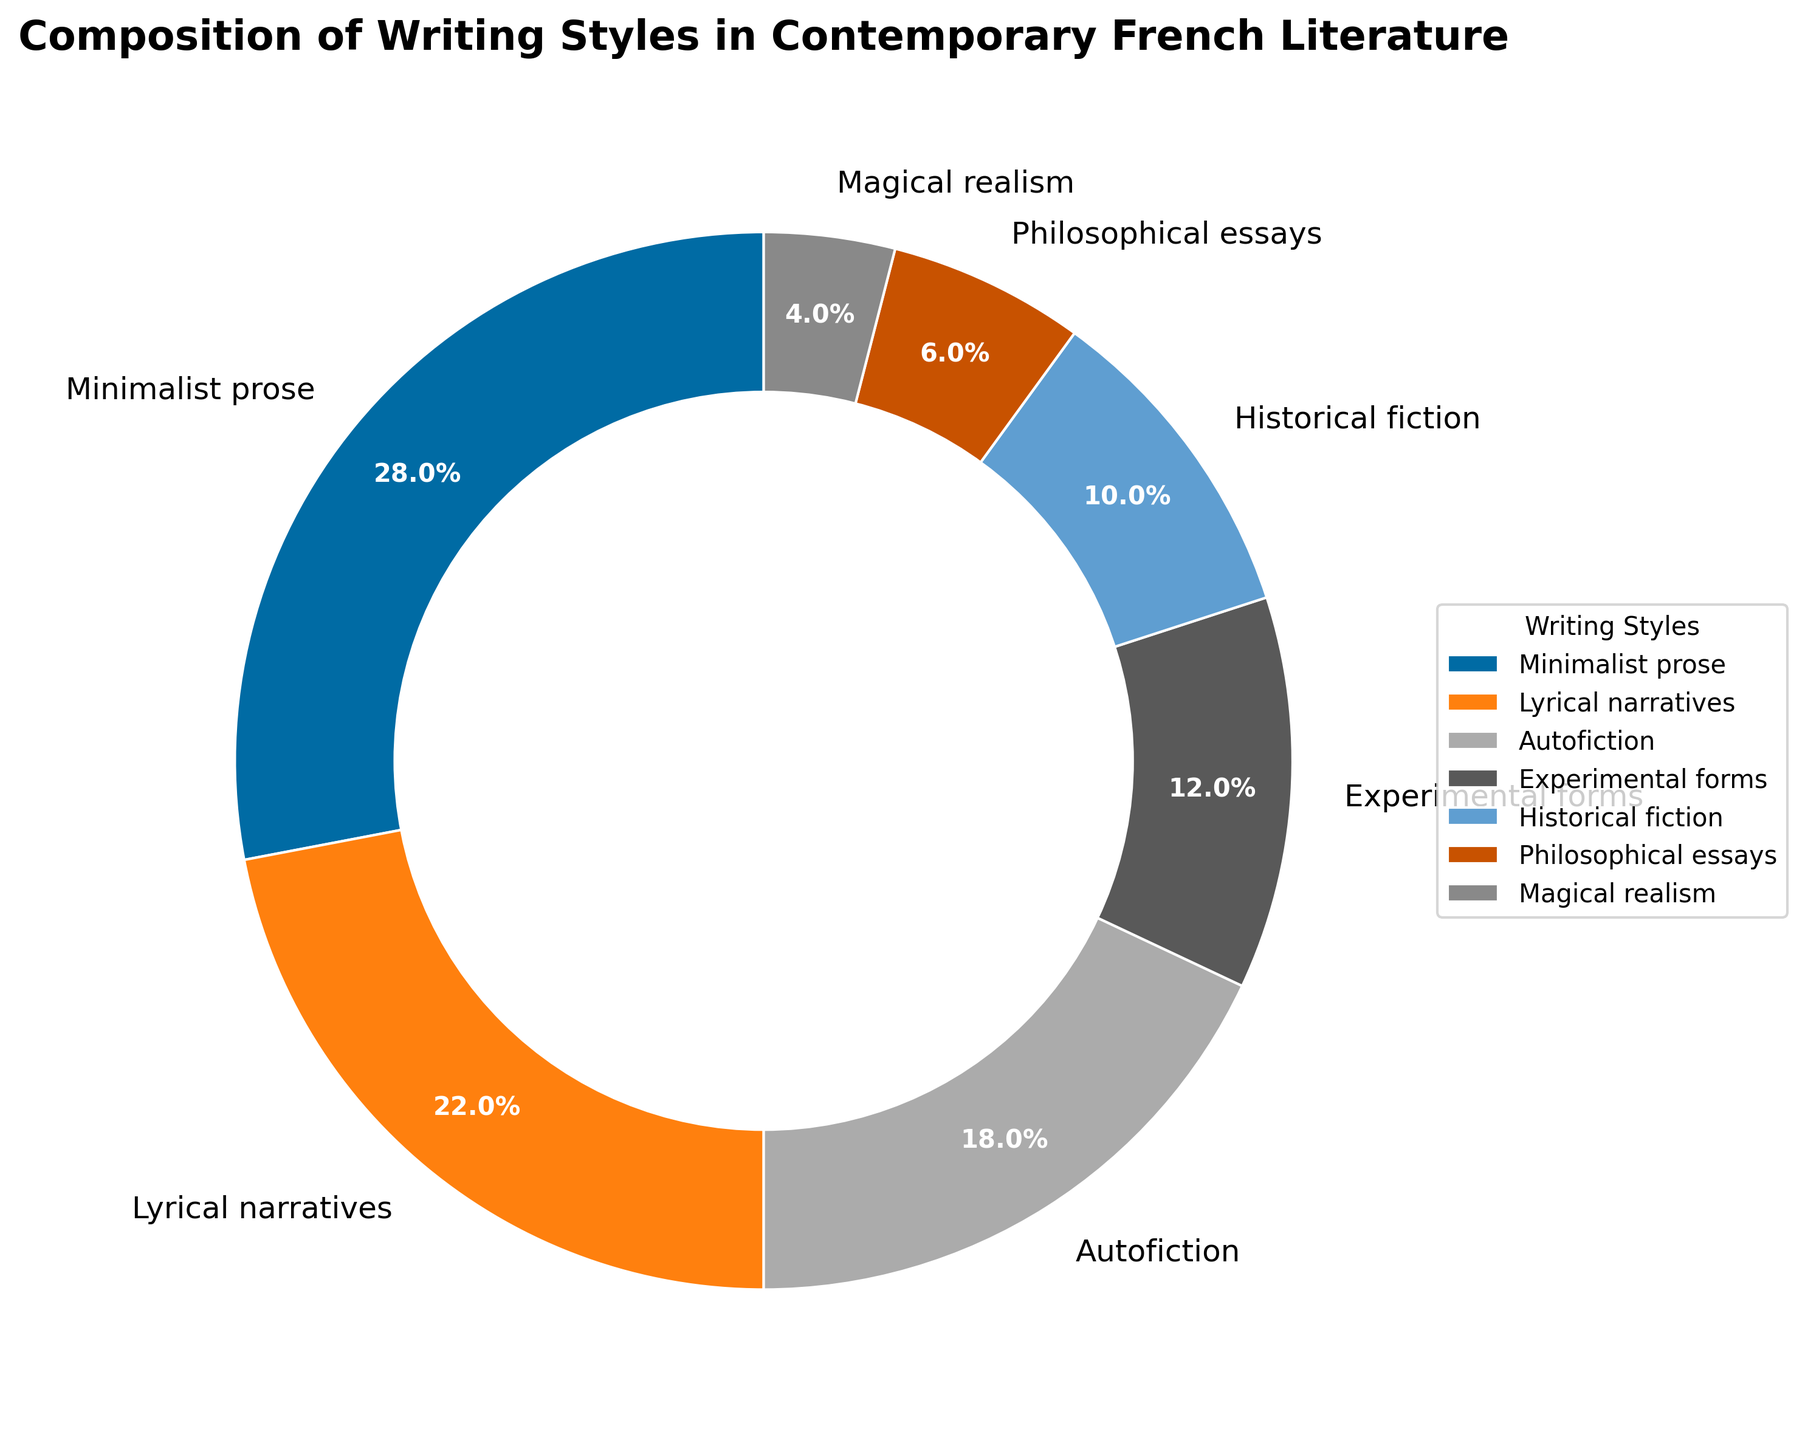what percentage of writing styles falls under "Lyrical narratives" and "Historical fiction" combined? To find the combined percentage, add the percentage for "Lyrical narratives" (22%) and "Historical fiction" (10%). So it's 22% + 10%.
Answer: 32% which writing style occupies the smallest portion of the pie chart? Examine the percentages for all writing styles and identify the smallest value. It's "Magical realism" with 4%.
Answer: Magical realism how much more prevalent is "Minimalist prose" compared to "Philosophical essays"? Subtract the percentage of "Philosophical essays" (6%) from "Minimalist prose" (28%). So it's 28% - 6%.
Answer: 22% how does the percentage of "Autofiction" compare to the sum of "Experimental forms" and "Magical realism"? Compare "Autofiction" (18%) with the sum of "Experimental forms" (12%) and "Magical realism" (4%). The sum is 12% + 4%, which is 16%. Autofiction is 2% higher.
Answer: 2% higher what’s the total percentage covered by "Experimental forms," "Historical fiction," and "Philosophical essays"? Add the percentages of these three categories: "Experimental forms" (12%), "Historical fiction" (10%), and "Philosophical essays" (6%). So, it's 12% + 10% + 6%.
Answer: 28% which writing style has the second-highest representation in the pie chart? Look at the percentages and identify the second-highest value. "Lyrical narratives" comes after "Minimalist prose" with 22%.
Answer: Lyrical narratives between "Autofiction" and "Magical realism," which one is less frequent and by how much? Subtract the percentage of "Magical realism" (4%) from "Autofiction" (18%). So, it's 18% - 4%.
Answer: Autofiction, 14% more how does the visual width of wedges for "Minimalist prose" and "Experimental forms" compare? Observe the wedges for "Minimalist prose" (28%) and "Experimental forms" (12%). "Minimalist prose" covers a significantly larger visual area than "Experimental forms".
Answer: Minimalist prose is wider what categories make up more than 50% of the writing styles in total? Determine which categories, when added together, exceed 50%. "Minimalist prose" (28%) and "Lyrical narratives" (22%) together make 50%. Adding any other category will exceed 50%.
Answer: Minimalist prose and Lyrical narratives combined make 50% how does the area covered by "Historical fiction" visually compare to "Experimental forms"? "Historical fiction" has 10%, which is less than "Experimental forms" at 12%. Therefore, "Experimental forms" should visually occupy a slightly larger section.
Answer: Experimental forms is slightly larger 